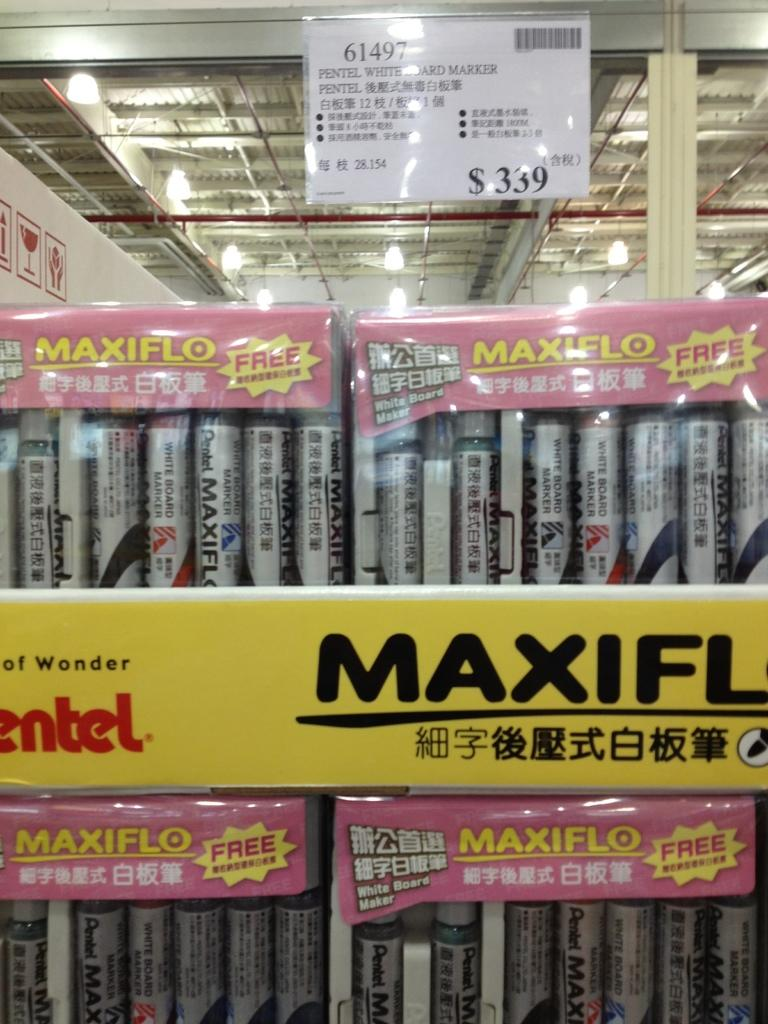<image>
Summarize the visual content of the image. a display of Maxiflo paint that cost $339 